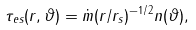Convert formula to latex. <formula><loc_0><loc_0><loc_500><loc_500>\tau _ { e s } ( r , \vartheta ) = \dot { m } ( r / r _ { s } ) ^ { - 1 / 2 } n ( \vartheta ) ,</formula> 